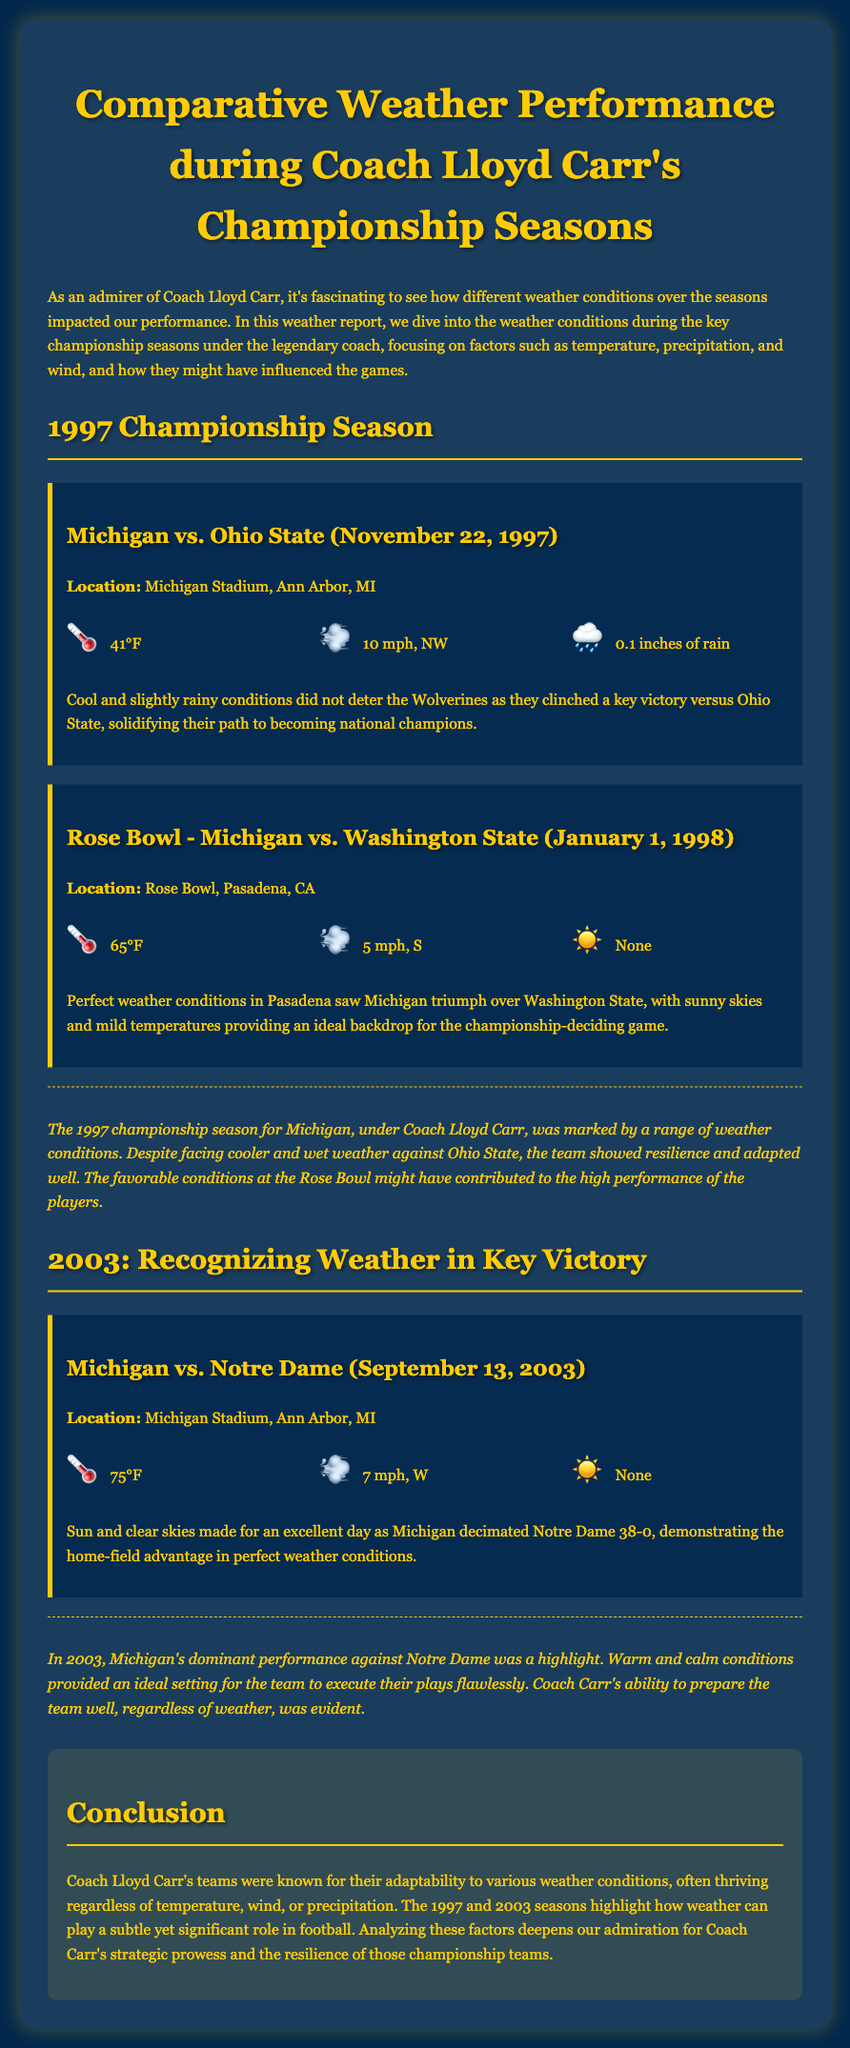what was the weather during the Michigan vs. Ohio State game? The weather conditions were 41°F, 10 mph NW wind, and 0.1 inches of rain.
Answer: 41°F, 10 mph NW, 0.1 inches of rain what was the location of the Rose Bowl game in 1998? The Rose Bowl game was held in Pasadena, California.
Answer: Pasadena, CA how many inches of rain were recorded in the 1997 Ohio State game? The document states that there was 0.1 inches of rain during that game.
Answer: 0.1 inches what temperature was recorded during the Michigan vs. Notre Dame match in 2003? The temperature was 75°F during the game against Notre Dame.
Answer: 75°F what was the main advantage noted during the Michigan vs. Notre Dame game in 2003? The main advantage noted was the home-field advantage in perfect weather conditions.
Answer: Home-field advantage how did the weather affect the 1997 Championship performance? The team showed resilience despite cooler and wet weather conditions.
Answer: Resilience what were the wind conditions during the Rose Bowl game in 1998? The wind was recorded at 5 mph coming from the south.
Answer: 5 mph, S what notable feature characterized the weather during the 2003 Michigan vs. Notre Dame game? The weather was characterized by sun and clear skies.
Answer: Sun and clear skies what conclusion can be drawn about Coach Carr's teams regarding weather conditions? Coach Carr's teams were known for their adaptability to various weather conditions.
Answer: Adaptability 